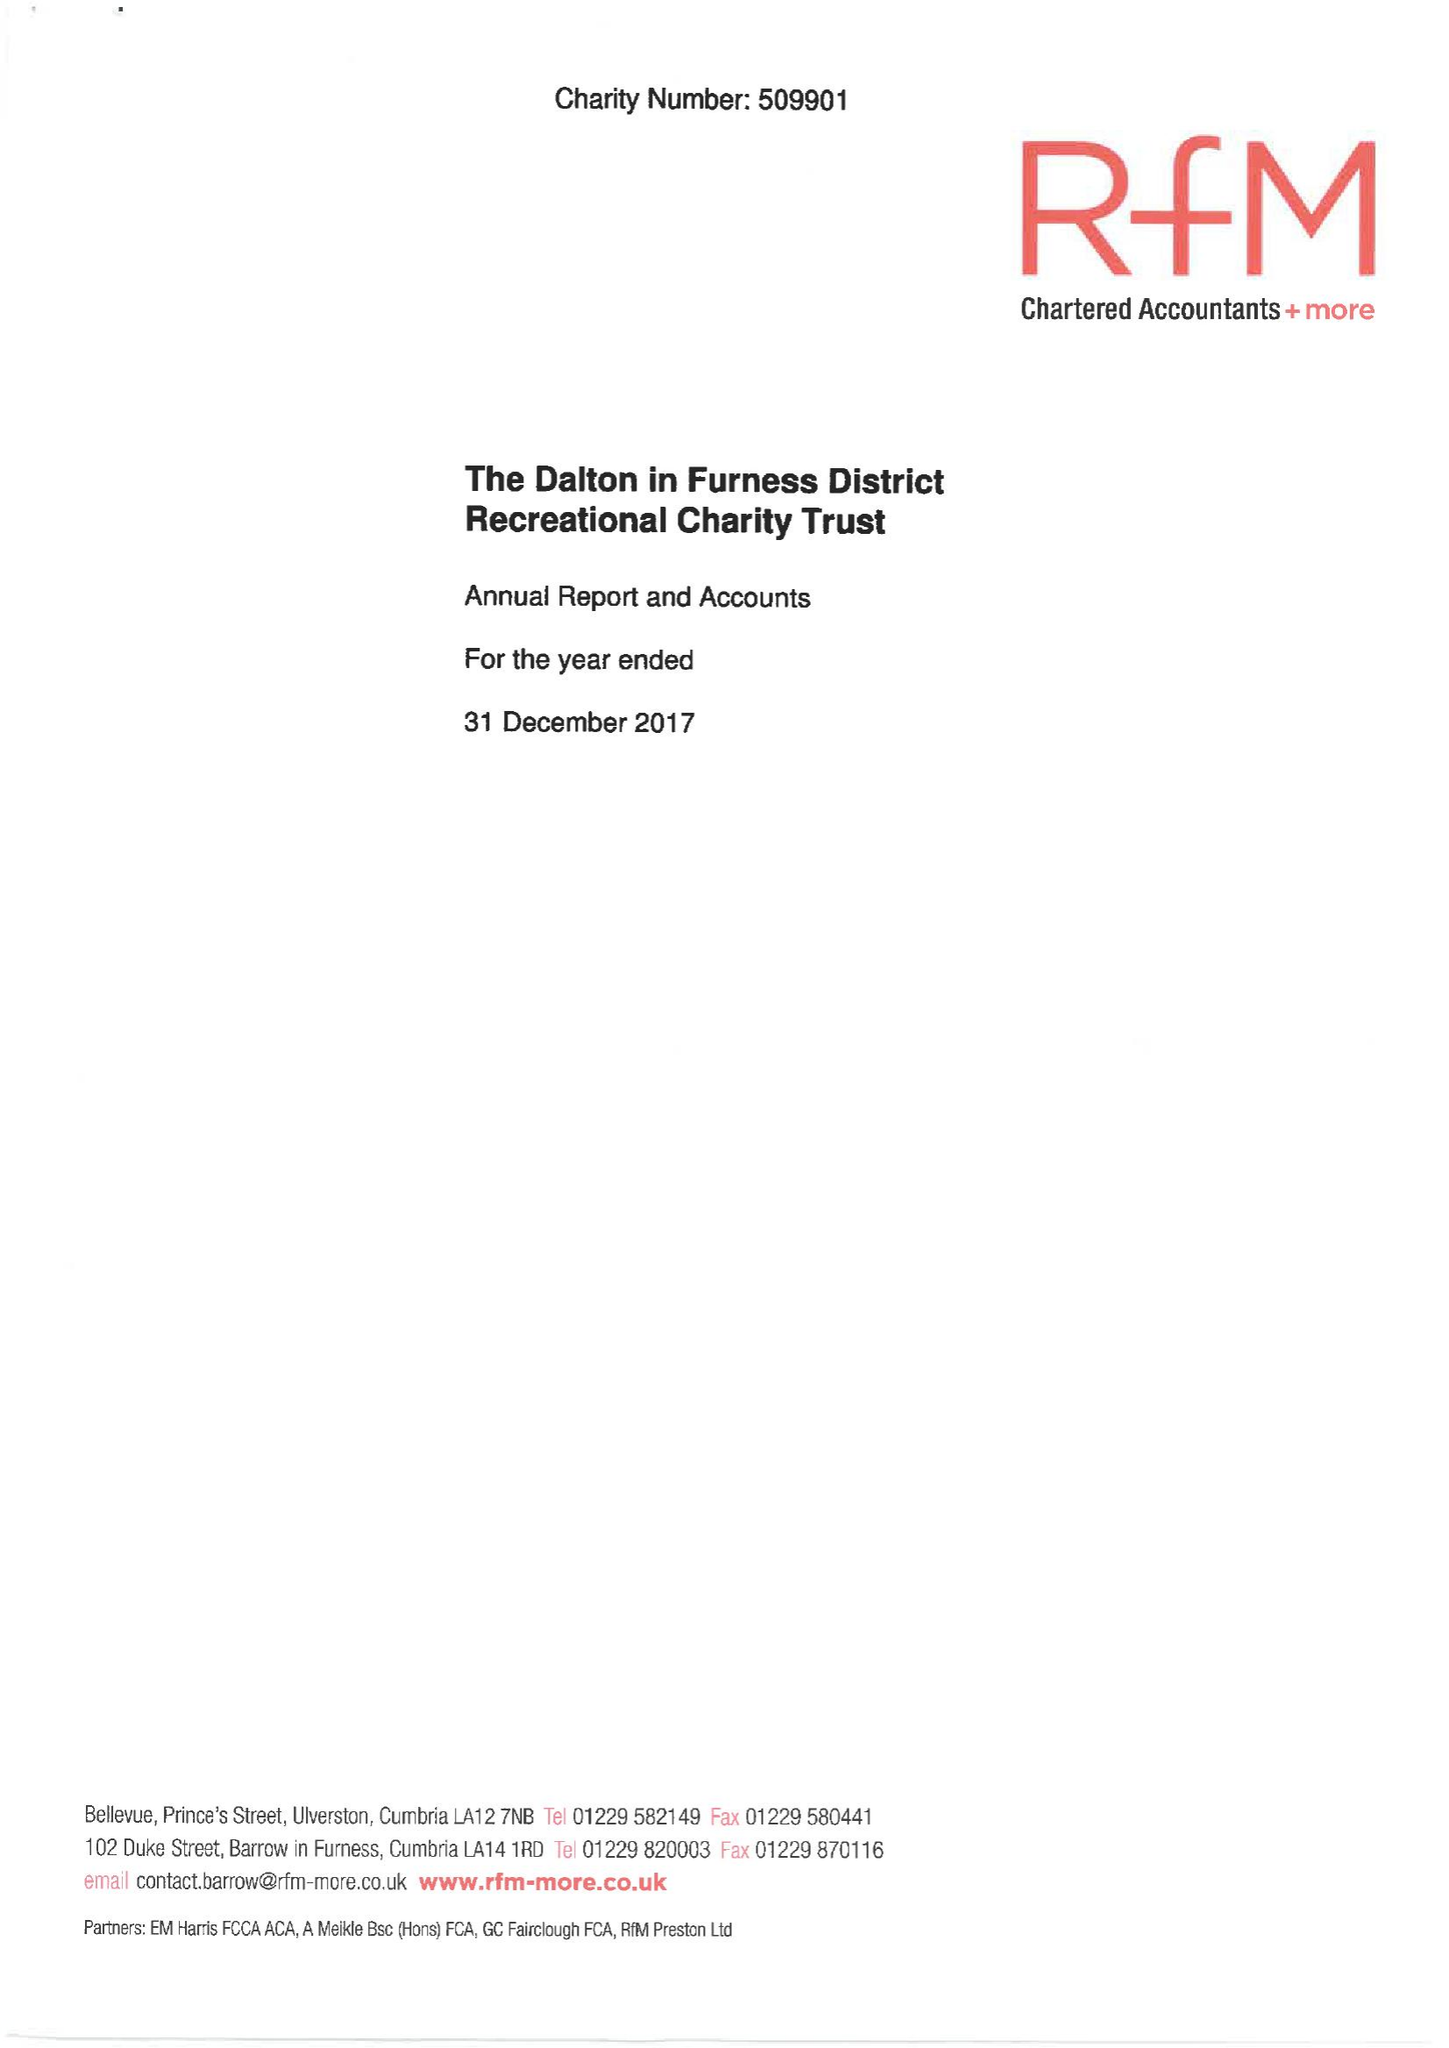What is the value for the report_date?
Answer the question using a single word or phrase. 2017-12-31 